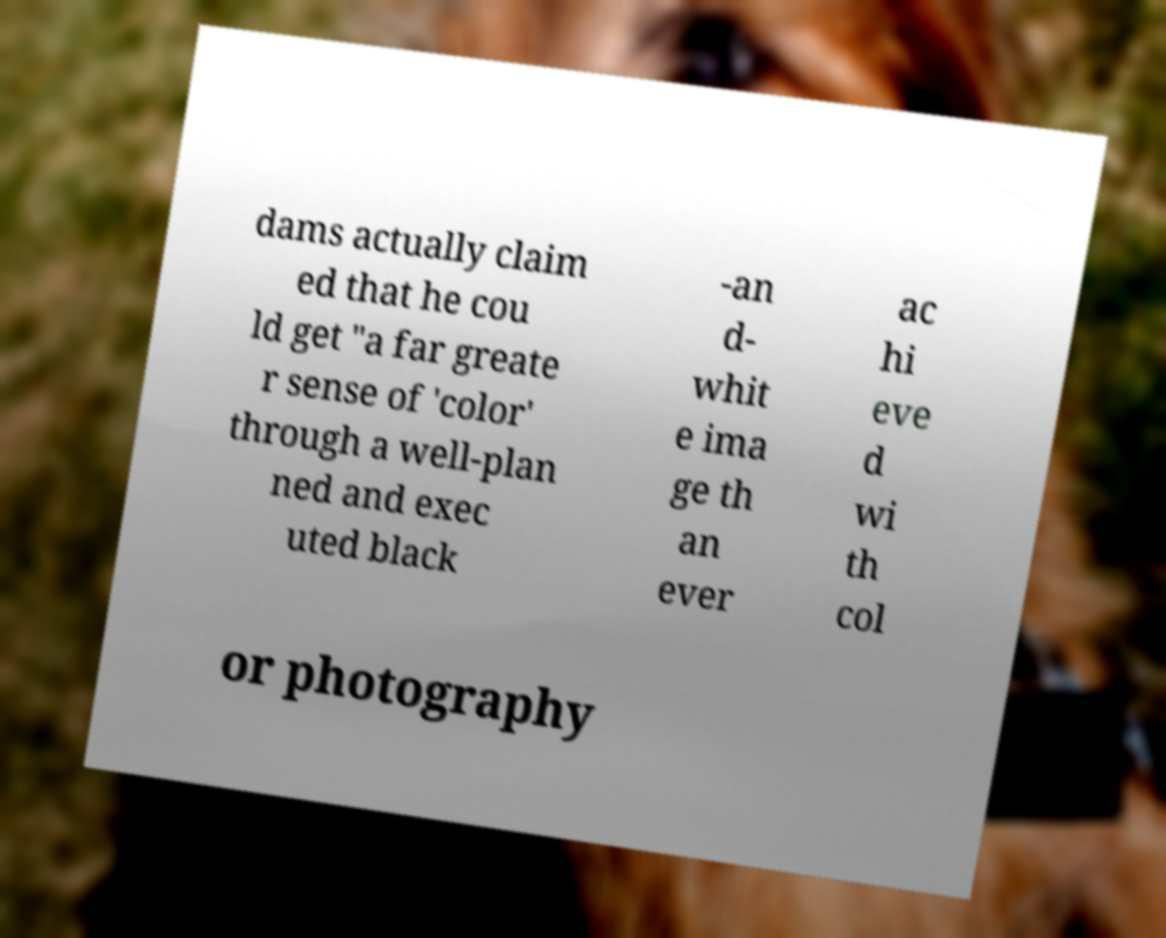Please read and relay the text visible in this image. What does it say? dams actually claim ed that he cou ld get "a far greate r sense of 'color' through a well-plan ned and exec uted black -an d- whit e ima ge th an ever ac hi eve d wi th col or photography 